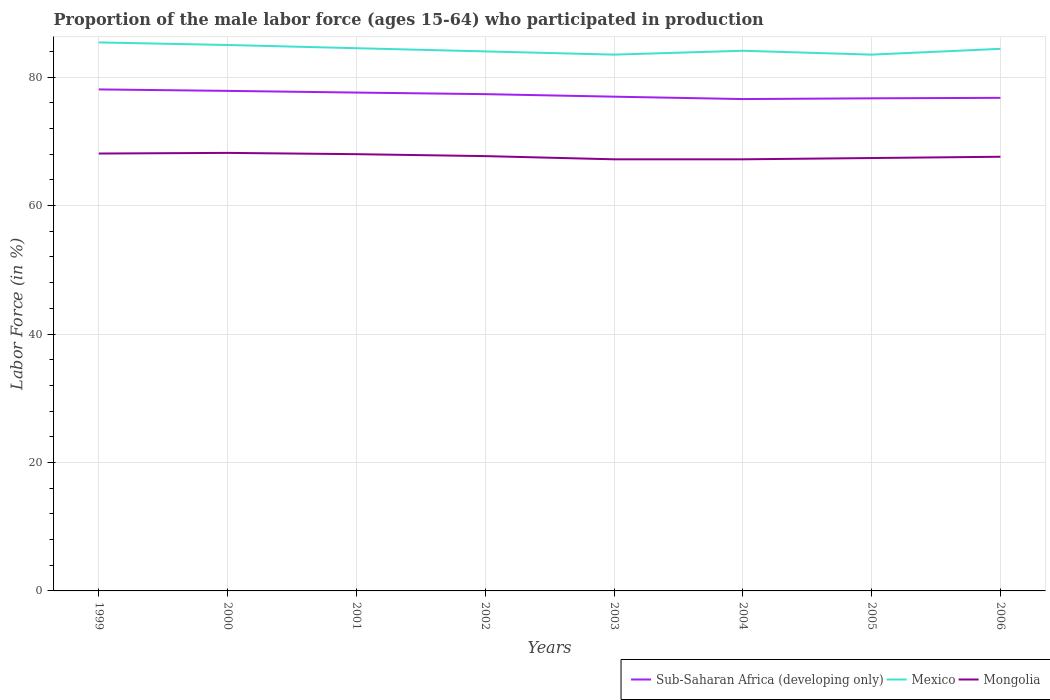Does the line corresponding to Mongolia intersect with the line corresponding to Mexico?
Your response must be concise. No. Across all years, what is the maximum proportion of the male labor force who participated in production in Sub-Saharan Africa (developing only)?
Your answer should be compact. 76.58. In which year was the proportion of the male labor force who participated in production in Mexico maximum?
Your answer should be compact. 2003. What is the total proportion of the male labor force who participated in production in Mongolia in the graph?
Your answer should be very brief. 0.5. What is the difference between the highest and the lowest proportion of the male labor force who participated in production in Mongolia?
Your answer should be very brief. 4. Are the values on the major ticks of Y-axis written in scientific E-notation?
Offer a terse response. No. Does the graph contain any zero values?
Make the answer very short. No. Where does the legend appear in the graph?
Your answer should be compact. Bottom right. How many legend labels are there?
Offer a very short reply. 3. How are the legend labels stacked?
Ensure brevity in your answer.  Horizontal. What is the title of the graph?
Offer a very short reply. Proportion of the male labor force (ages 15-64) who participated in production. What is the label or title of the Y-axis?
Provide a short and direct response. Labor Force (in %). What is the Labor Force (in %) of Sub-Saharan Africa (developing only) in 1999?
Give a very brief answer. 78.08. What is the Labor Force (in %) in Mexico in 1999?
Ensure brevity in your answer.  85.4. What is the Labor Force (in %) of Mongolia in 1999?
Your response must be concise. 68.1. What is the Labor Force (in %) of Sub-Saharan Africa (developing only) in 2000?
Your answer should be compact. 77.85. What is the Labor Force (in %) in Mongolia in 2000?
Keep it short and to the point. 68.2. What is the Labor Force (in %) in Sub-Saharan Africa (developing only) in 2001?
Give a very brief answer. 77.59. What is the Labor Force (in %) of Mexico in 2001?
Provide a short and direct response. 84.5. What is the Labor Force (in %) in Sub-Saharan Africa (developing only) in 2002?
Your answer should be compact. 77.35. What is the Labor Force (in %) of Mexico in 2002?
Offer a terse response. 84. What is the Labor Force (in %) in Mongolia in 2002?
Your answer should be very brief. 67.7. What is the Labor Force (in %) of Sub-Saharan Africa (developing only) in 2003?
Provide a succinct answer. 76.95. What is the Labor Force (in %) of Mexico in 2003?
Offer a very short reply. 83.5. What is the Labor Force (in %) of Mongolia in 2003?
Provide a short and direct response. 67.2. What is the Labor Force (in %) in Sub-Saharan Africa (developing only) in 2004?
Make the answer very short. 76.58. What is the Labor Force (in %) in Mexico in 2004?
Keep it short and to the point. 84.1. What is the Labor Force (in %) of Mongolia in 2004?
Provide a short and direct response. 67.2. What is the Labor Force (in %) of Sub-Saharan Africa (developing only) in 2005?
Your response must be concise. 76.7. What is the Labor Force (in %) of Mexico in 2005?
Your response must be concise. 83.5. What is the Labor Force (in %) of Mongolia in 2005?
Give a very brief answer. 67.4. What is the Labor Force (in %) in Sub-Saharan Africa (developing only) in 2006?
Make the answer very short. 76.77. What is the Labor Force (in %) of Mexico in 2006?
Offer a very short reply. 84.4. What is the Labor Force (in %) of Mongolia in 2006?
Ensure brevity in your answer.  67.6. Across all years, what is the maximum Labor Force (in %) of Sub-Saharan Africa (developing only)?
Ensure brevity in your answer.  78.08. Across all years, what is the maximum Labor Force (in %) of Mexico?
Offer a very short reply. 85.4. Across all years, what is the maximum Labor Force (in %) of Mongolia?
Provide a short and direct response. 68.2. Across all years, what is the minimum Labor Force (in %) in Sub-Saharan Africa (developing only)?
Make the answer very short. 76.58. Across all years, what is the minimum Labor Force (in %) in Mexico?
Provide a succinct answer. 83.5. Across all years, what is the minimum Labor Force (in %) in Mongolia?
Ensure brevity in your answer.  67.2. What is the total Labor Force (in %) of Sub-Saharan Africa (developing only) in the graph?
Give a very brief answer. 617.88. What is the total Labor Force (in %) in Mexico in the graph?
Your answer should be compact. 674.4. What is the total Labor Force (in %) of Mongolia in the graph?
Your response must be concise. 541.4. What is the difference between the Labor Force (in %) of Sub-Saharan Africa (developing only) in 1999 and that in 2000?
Your answer should be compact. 0.23. What is the difference between the Labor Force (in %) in Mongolia in 1999 and that in 2000?
Offer a very short reply. -0.1. What is the difference between the Labor Force (in %) in Sub-Saharan Africa (developing only) in 1999 and that in 2001?
Your answer should be very brief. 0.49. What is the difference between the Labor Force (in %) of Mexico in 1999 and that in 2001?
Make the answer very short. 0.9. What is the difference between the Labor Force (in %) in Sub-Saharan Africa (developing only) in 1999 and that in 2002?
Your response must be concise. 0.73. What is the difference between the Labor Force (in %) of Mongolia in 1999 and that in 2002?
Give a very brief answer. 0.4. What is the difference between the Labor Force (in %) of Sub-Saharan Africa (developing only) in 1999 and that in 2003?
Give a very brief answer. 1.13. What is the difference between the Labor Force (in %) in Sub-Saharan Africa (developing only) in 1999 and that in 2004?
Provide a short and direct response. 1.5. What is the difference between the Labor Force (in %) of Mongolia in 1999 and that in 2004?
Offer a terse response. 0.9. What is the difference between the Labor Force (in %) of Sub-Saharan Africa (developing only) in 1999 and that in 2005?
Give a very brief answer. 1.38. What is the difference between the Labor Force (in %) in Mexico in 1999 and that in 2005?
Ensure brevity in your answer.  1.9. What is the difference between the Labor Force (in %) of Sub-Saharan Africa (developing only) in 1999 and that in 2006?
Make the answer very short. 1.31. What is the difference between the Labor Force (in %) of Mexico in 1999 and that in 2006?
Your answer should be very brief. 1. What is the difference between the Labor Force (in %) of Mongolia in 1999 and that in 2006?
Provide a succinct answer. 0.5. What is the difference between the Labor Force (in %) of Sub-Saharan Africa (developing only) in 2000 and that in 2001?
Provide a short and direct response. 0.26. What is the difference between the Labor Force (in %) of Mongolia in 2000 and that in 2001?
Give a very brief answer. 0.2. What is the difference between the Labor Force (in %) in Sub-Saharan Africa (developing only) in 2000 and that in 2002?
Provide a succinct answer. 0.51. What is the difference between the Labor Force (in %) of Mexico in 2000 and that in 2002?
Keep it short and to the point. 1. What is the difference between the Labor Force (in %) of Mongolia in 2000 and that in 2002?
Your answer should be compact. 0.5. What is the difference between the Labor Force (in %) in Sub-Saharan Africa (developing only) in 2000 and that in 2003?
Offer a very short reply. 0.9. What is the difference between the Labor Force (in %) in Mexico in 2000 and that in 2003?
Provide a short and direct response. 1.5. What is the difference between the Labor Force (in %) in Mongolia in 2000 and that in 2003?
Keep it short and to the point. 1. What is the difference between the Labor Force (in %) in Sub-Saharan Africa (developing only) in 2000 and that in 2004?
Provide a succinct answer. 1.27. What is the difference between the Labor Force (in %) of Mexico in 2000 and that in 2004?
Give a very brief answer. 0.9. What is the difference between the Labor Force (in %) of Sub-Saharan Africa (developing only) in 2000 and that in 2005?
Provide a short and direct response. 1.16. What is the difference between the Labor Force (in %) in Mexico in 2000 and that in 2005?
Provide a short and direct response. 1.5. What is the difference between the Labor Force (in %) in Mongolia in 2000 and that in 2005?
Offer a terse response. 0.8. What is the difference between the Labor Force (in %) in Sub-Saharan Africa (developing only) in 2000 and that in 2006?
Ensure brevity in your answer.  1.09. What is the difference between the Labor Force (in %) of Mexico in 2000 and that in 2006?
Provide a short and direct response. 0.6. What is the difference between the Labor Force (in %) of Mongolia in 2000 and that in 2006?
Provide a short and direct response. 0.6. What is the difference between the Labor Force (in %) of Sub-Saharan Africa (developing only) in 2001 and that in 2002?
Ensure brevity in your answer.  0.24. What is the difference between the Labor Force (in %) in Sub-Saharan Africa (developing only) in 2001 and that in 2003?
Your answer should be compact. 0.64. What is the difference between the Labor Force (in %) of Mexico in 2001 and that in 2003?
Offer a very short reply. 1. What is the difference between the Labor Force (in %) in Sub-Saharan Africa (developing only) in 2001 and that in 2004?
Keep it short and to the point. 1.01. What is the difference between the Labor Force (in %) of Mexico in 2001 and that in 2004?
Your response must be concise. 0.4. What is the difference between the Labor Force (in %) of Mongolia in 2001 and that in 2004?
Give a very brief answer. 0.8. What is the difference between the Labor Force (in %) in Sub-Saharan Africa (developing only) in 2001 and that in 2005?
Provide a short and direct response. 0.9. What is the difference between the Labor Force (in %) of Sub-Saharan Africa (developing only) in 2001 and that in 2006?
Give a very brief answer. 0.82. What is the difference between the Labor Force (in %) in Mongolia in 2001 and that in 2006?
Provide a short and direct response. 0.4. What is the difference between the Labor Force (in %) in Sub-Saharan Africa (developing only) in 2002 and that in 2003?
Your response must be concise. 0.4. What is the difference between the Labor Force (in %) of Mexico in 2002 and that in 2003?
Give a very brief answer. 0.5. What is the difference between the Labor Force (in %) in Sub-Saharan Africa (developing only) in 2002 and that in 2004?
Your answer should be very brief. 0.77. What is the difference between the Labor Force (in %) in Mexico in 2002 and that in 2004?
Offer a terse response. -0.1. What is the difference between the Labor Force (in %) in Mongolia in 2002 and that in 2004?
Keep it short and to the point. 0.5. What is the difference between the Labor Force (in %) of Sub-Saharan Africa (developing only) in 2002 and that in 2005?
Give a very brief answer. 0.65. What is the difference between the Labor Force (in %) in Sub-Saharan Africa (developing only) in 2002 and that in 2006?
Your response must be concise. 0.58. What is the difference between the Labor Force (in %) of Mexico in 2002 and that in 2006?
Make the answer very short. -0.4. What is the difference between the Labor Force (in %) of Sub-Saharan Africa (developing only) in 2003 and that in 2004?
Your answer should be very brief. 0.37. What is the difference between the Labor Force (in %) in Mexico in 2003 and that in 2004?
Offer a very short reply. -0.6. What is the difference between the Labor Force (in %) in Sub-Saharan Africa (developing only) in 2003 and that in 2005?
Offer a terse response. 0.26. What is the difference between the Labor Force (in %) of Mexico in 2003 and that in 2005?
Ensure brevity in your answer.  0. What is the difference between the Labor Force (in %) of Sub-Saharan Africa (developing only) in 2003 and that in 2006?
Your answer should be compact. 0.18. What is the difference between the Labor Force (in %) in Mexico in 2003 and that in 2006?
Your response must be concise. -0.9. What is the difference between the Labor Force (in %) in Mongolia in 2003 and that in 2006?
Keep it short and to the point. -0.4. What is the difference between the Labor Force (in %) in Sub-Saharan Africa (developing only) in 2004 and that in 2005?
Offer a very short reply. -0.12. What is the difference between the Labor Force (in %) of Mexico in 2004 and that in 2005?
Keep it short and to the point. 0.6. What is the difference between the Labor Force (in %) in Sub-Saharan Africa (developing only) in 2004 and that in 2006?
Ensure brevity in your answer.  -0.19. What is the difference between the Labor Force (in %) of Mexico in 2004 and that in 2006?
Your answer should be compact. -0.3. What is the difference between the Labor Force (in %) of Sub-Saharan Africa (developing only) in 2005 and that in 2006?
Your response must be concise. -0.07. What is the difference between the Labor Force (in %) of Mexico in 2005 and that in 2006?
Offer a terse response. -0.9. What is the difference between the Labor Force (in %) of Mongolia in 2005 and that in 2006?
Offer a terse response. -0.2. What is the difference between the Labor Force (in %) in Sub-Saharan Africa (developing only) in 1999 and the Labor Force (in %) in Mexico in 2000?
Provide a succinct answer. -6.92. What is the difference between the Labor Force (in %) in Sub-Saharan Africa (developing only) in 1999 and the Labor Force (in %) in Mongolia in 2000?
Your answer should be compact. 9.88. What is the difference between the Labor Force (in %) in Sub-Saharan Africa (developing only) in 1999 and the Labor Force (in %) in Mexico in 2001?
Make the answer very short. -6.42. What is the difference between the Labor Force (in %) of Sub-Saharan Africa (developing only) in 1999 and the Labor Force (in %) of Mongolia in 2001?
Provide a short and direct response. 10.08. What is the difference between the Labor Force (in %) in Mexico in 1999 and the Labor Force (in %) in Mongolia in 2001?
Ensure brevity in your answer.  17.4. What is the difference between the Labor Force (in %) of Sub-Saharan Africa (developing only) in 1999 and the Labor Force (in %) of Mexico in 2002?
Your answer should be very brief. -5.92. What is the difference between the Labor Force (in %) in Sub-Saharan Africa (developing only) in 1999 and the Labor Force (in %) in Mongolia in 2002?
Your answer should be compact. 10.38. What is the difference between the Labor Force (in %) in Mexico in 1999 and the Labor Force (in %) in Mongolia in 2002?
Give a very brief answer. 17.7. What is the difference between the Labor Force (in %) of Sub-Saharan Africa (developing only) in 1999 and the Labor Force (in %) of Mexico in 2003?
Ensure brevity in your answer.  -5.42. What is the difference between the Labor Force (in %) in Sub-Saharan Africa (developing only) in 1999 and the Labor Force (in %) in Mongolia in 2003?
Offer a terse response. 10.88. What is the difference between the Labor Force (in %) in Sub-Saharan Africa (developing only) in 1999 and the Labor Force (in %) in Mexico in 2004?
Provide a succinct answer. -6.02. What is the difference between the Labor Force (in %) in Sub-Saharan Africa (developing only) in 1999 and the Labor Force (in %) in Mongolia in 2004?
Give a very brief answer. 10.88. What is the difference between the Labor Force (in %) of Sub-Saharan Africa (developing only) in 1999 and the Labor Force (in %) of Mexico in 2005?
Your answer should be compact. -5.42. What is the difference between the Labor Force (in %) in Sub-Saharan Africa (developing only) in 1999 and the Labor Force (in %) in Mongolia in 2005?
Your response must be concise. 10.68. What is the difference between the Labor Force (in %) of Mexico in 1999 and the Labor Force (in %) of Mongolia in 2005?
Your response must be concise. 18. What is the difference between the Labor Force (in %) in Sub-Saharan Africa (developing only) in 1999 and the Labor Force (in %) in Mexico in 2006?
Provide a succinct answer. -6.32. What is the difference between the Labor Force (in %) of Sub-Saharan Africa (developing only) in 1999 and the Labor Force (in %) of Mongolia in 2006?
Offer a very short reply. 10.48. What is the difference between the Labor Force (in %) of Mexico in 1999 and the Labor Force (in %) of Mongolia in 2006?
Keep it short and to the point. 17.8. What is the difference between the Labor Force (in %) of Sub-Saharan Africa (developing only) in 2000 and the Labor Force (in %) of Mexico in 2001?
Offer a very short reply. -6.65. What is the difference between the Labor Force (in %) in Sub-Saharan Africa (developing only) in 2000 and the Labor Force (in %) in Mongolia in 2001?
Your answer should be very brief. 9.85. What is the difference between the Labor Force (in %) of Sub-Saharan Africa (developing only) in 2000 and the Labor Force (in %) of Mexico in 2002?
Give a very brief answer. -6.15. What is the difference between the Labor Force (in %) in Sub-Saharan Africa (developing only) in 2000 and the Labor Force (in %) in Mongolia in 2002?
Make the answer very short. 10.15. What is the difference between the Labor Force (in %) of Sub-Saharan Africa (developing only) in 2000 and the Labor Force (in %) of Mexico in 2003?
Give a very brief answer. -5.65. What is the difference between the Labor Force (in %) of Sub-Saharan Africa (developing only) in 2000 and the Labor Force (in %) of Mongolia in 2003?
Provide a short and direct response. 10.65. What is the difference between the Labor Force (in %) of Mexico in 2000 and the Labor Force (in %) of Mongolia in 2003?
Your answer should be very brief. 17.8. What is the difference between the Labor Force (in %) of Sub-Saharan Africa (developing only) in 2000 and the Labor Force (in %) of Mexico in 2004?
Keep it short and to the point. -6.25. What is the difference between the Labor Force (in %) in Sub-Saharan Africa (developing only) in 2000 and the Labor Force (in %) in Mongolia in 2004?
Give a very brief answer. 10.65. What is the difference between the Labor Force (in %) of Mexico in 2000 and the Labor Force (in %) of Mongolia in 2004?
Give a very brief answer. 17.8. What is the difference between the Labor Force (in %) of Sub-Saharan Africa (developing only) in 2000 and the Labor Force (in %) of Mexico in 2005?
Ensure brevity in your answer.  -5.65. What is the difference between the Labor Force (in %) in Sub-Saharan Africa (developing only) in 2000 and the Labor Force (in %) in Mongolia in 2005?
Offer a very short reply. 10.45. What is the difference between the Labor Force (in %) of Mexico in 2000 and the Labor Force (in %) of Mongolia in 2005?
Provide a succinct answer. 17.6. What is the difference between the Labor Force (in %) in Sub-Saharan Africa (developing only) in 2000 and the Labor Force (in %) in Mexico in 2006?
Offer a very short reply. -6.55. What is the difference between the Labor Force (in %) in Sub-Saharan Africa (developing only) in 2000 and the Labor Force (in %) in Mongolia in 2006?
Keep it short and to the point. 10.25. What is the difference between the Labor Force (in %) in Mexico in 2000 and the Labor Force (in %) in Mongolia in 2006?
Make the answer very short. 17.4. What is the difference between the Labor Force (in %) in Sub-Saharan Africa (developing only) in 2001 and the Labor Force (in %) in Mexico in 2002?
Keep it short and to the point. -6.41. What is the difference between the Labor Force (in %) in Sub-Saharan Africa (developing only) in 2001 and the Labor Force (in %) in Mongolia in 2002?
Give a very brief answer. 9.89. What is the difference between the Labor Force (in %) in Mexico in 2001 and the Labor Force (in %) in Mongolia in 2002?
Offer a very short reply. 16.8. What is the difference between the Labor Force (in %) in Sub-Saharan Africa (developing only) in 2001 and the Labor Force (in %) in Mexico in 2003?
Your answer should be compact. -5.91. What is the difference between the Labor Force (in %) of Sub-Saharan Africa (developing only) in 2001 and the Labor Force (in %) of Mongolia in 2003?
Your answer should be compact. 10.39. What is the difference between the Labor Force (in %) in Sub-Saharan Africa (developing only) in 2001 and the Labor Force (in %) in Mexico in 2004?
Make the answer very short. -6.51. What is the difference between the Labor Force (in %) in Sub-Saharan Africa (developing only) in 2001 and the Labor Force (in %) in Mongolia in 2004?
Your answer should be compact. 10.39. What is the difference between the Labor Force (in %) of Mexico in 2001 and the Labor Force (in %) of Mongolia in 2004?
Provide a short and direct response. 17.3. What is the difference between the Labor Force (in %) in Sub-Saharan Africa (developing only) in 2001 and the Labor Force (in %) in Mexico in 2005?
Your answer should be compact. -5.91. What is the difference between the Labor Force (in %) of Sub-Saharan Africa (developing only) in 2001 and the Labor Force (in %) of Mongolia in 2005?
Your answer should be very brief. 10.19. What is the difference between the Labor Force (in %) of Mexico in 2001 and the Labor Force (in %) of Mongolia in 2005?
Offer a very short reply. 17.1. What is the difference between the Labor Force (in %) of Sub-Saharan Africa (developing only) in 2001 and the Labor Force (in %) of Mexico in 2006?
Your answer should be compact. -6.81. What is the difference between the Labor Force (in %) in Sub-Saharan Africa (developing only) in 2001 and the Labor Force (in %) in Mongolia in 2006?
Provide a short and direct response. 9.99. What is the difference between the Labor Force (in %) in Sub-Saharan Africa (developing only) in 2002 and the Labor Force (in %) in Mexico in 2003?
Keep it short and to the point. -6.15. What is the difference between the Labor Force (in %) of Sub-Saharan Africa (developing only) in 2002 and the Labor Force (in %) of Mongolia in 2003?
Offer a very short reply. 10.15. What is the difference between the Labor Force (in %) in Sub-Saharan Africa (developing only) in 2002 and the Labor Force (in %) in Mexico in 2004?
Keep it short and to the point. -6.75. What is the difference between the Labor Force (in %) of Sub-Saharan Africa (developing only) in 2002 and the Labor Force (in %) of Mongolia in 2004?
Offer a very short reply. 10.15. What is the difference between the Labor Force (in %) of Mexico in 2002 and the Labor Force (in %) of Mongolia in 2004?
Your response must be concise. 16.8. What is the difference between the Labor Force (in %) in Sub-Saharan Africa (developing only) in 2002 and the Labor Force (in %) in Mexico in 2005?
Provide a short and direct response. -6.15. What is the difference between the Labor Force (in %) of Sub-Saharan Africa (developing only) in 2002 and the Labor Force (in %) of Mongolia in 2005?
Your answer should be very brief. 9.95. What is the difference between the Labor Force (in %) in Sub-Saharan Africa (developing only) in 2002 and the Labor Force (in %) in Mexico in 2006?
Ensure brevity in your answer.  -7.05. What is the difference between the Labor Force (in %) in Sub-Saharan Africa (developing only) in 2002 and the Labor Force (in %) in Mongolia in 2006?
Your answer should be compact. 9.75. What is the difference between the Labor Force (in %) in Mexico in 2002 and the Labor Force (in %) in Mongolia in 2006?
Provide a succinct answer. 16.4. What is the difference between the Labor Force (in %) of Sub-Saharan Africa (developing only) in 2003 and the Labor Force (in %) of Mexico in 2004?
Provide a short and direct response. -7.15. What is the difference between the Labor Force (in %) of Sub-Saharan Africa (developing only) in 2003 and the Labor Force (in %) of Mongolia in 2004?
Your response must be concise. 9.75. What is the difference between the Labor Force (in %) of Mexico in 2003 and the Labor Force (in %) of Mongolia in 2004?
Your answer should be compact. 16.3. What is the difference between the Labor Force (in %) in Sub-Saharan Africa (developing only) in 2003 and the Labor Force (in %) in Mexico in 2005?
Provide a succinct answer. -6.55. What is the difference between the Labor Force (in %) of Sub-Saharan Africa (developing only) in 2003 and the Labor Force (in %) of Mongolia in 2005?
Your answer should be very brief. 9.55. What is the difference between the Labor Force (in %) in Mexico in 2003 and the Labor Force (in %) in Mongolia in 2005?
Provide a short and direct response. 16.1. What is the difference between the Labor Force (in %) of Sub-Saharan Africa (developing only) in 2003 and the Labor Force (in %) of Mexico in 2006?
Offer a terse response. -7.45. What is the difference between the Labor Force (in %) in Sub-Saharan Africa (developing only) in 2003 and the Labor Force (in %) in Mongolia in 2006?
Your response must be concise. 9.35. What is the difference between the Labor Force (in %) in Sub-Saharan Africa (developing only) in 2004 and the Labor Force (in %) in Mexico in 2005?
Your answer should be very brief. -6.92. What is the difference between the Labor Force (in %) of Sub-Saharan Africa (developing only) in 2004 and the Labor Force (in %) of Mongolia in 2005?
Your response must be concise. 9.18. What is the difference between the Labor Force (in %) in Mexico in 2004 and the Labor Force (in %) in Mongolia in 2005?
Your answer should be very brief. 16.7. What is the difference between the Labor Force (in %) in Sub-Saharan Africa (developing only) in 2004 and the Labor Force (in %) in Mexico in 2006?
Your response must be concise. -7.82. What is the difference between the Labor Force (in %) of Sub-Saharan Africa (developing only) in 2004 and the Labor Force (in %) of Mongolia in 2006?
Keep it short and to the point. 8.98. What is the difference between the Labor Force (in %) of Mexico in 2004 and the Labor Force (in %) of Mongolia in 2006?
Your response must be concise. 16.5. What is the difference between the Labor Force (in %) in Sub-Saharan Africa (developing only) in 2005 and the Labor Force (in %) in Mexico in 2006?
Your response must be concise. -7.7. What is the difference between the Labor Force (in %) of Sub-Saharan Africa (developing only) in 2005 and the Labor Force (in %) of Mongolia in 2006?
Offer a very short reply. 9.1. What is the average Labor Force (in %) in Sub-Saharan Africa (developing only) per year?
Offer a very short reply. 77.23. What is the average Labor Force (in %) in Mexico per year?
Offer a terse response. 84.3. What is the average Labor Force (in %) of Mongolia per year?
Offer a terse response. 67.67. In the year 1999, what is the difference between the Labor Force (in %) in Sub-Saharan Africa (developing only) and Labor Force (in %) in Mexico?
Offer a terse response. -7.32. In the year 1999, what is the difference between the Labor Force (in %) in Sub-Saharan Africa (developing only) and Labor Force (in %) in Mongolia?
Provide a short and direct response. 9.98. In the year 1999, what is the difference between the Labor Force (in %) of Mexico and Labor Force (in %) of Mongolia?
Your answer should be very brief. 17.3. In the year 2000, what is the difference between the Labor Force (in %) of Sub-Saharan Africa (developing only) and Labor Force (in %) of Mexico?
Make the answer very short. -7.15. In the year 2000, what is the difference between the Labor Force (in %) of Sub-Saharan Africa (developing only) and Labor Force (in %) of Mongolia?
Offer a terse response. 9.65. In the year 2001, what is the difference between the Labor Force (in %) of Sub-Saharan Africa (developing only) and Labor Force (in %) of Mexico?
Give a very brief answer. -6.91. In the year 2001, what is the difference between the Labor Force (in %) in Sub-Saharan Africa (developing only) and Labor Force (in %) in Mongolia?
Make the answer very short. 9.59. In the year 2002, what is the difference between the Labor Force (in %) of Sub-Saharan Africa (developing only) and Labor Force (in %) of Mexico?
Offer a terse response. -6.65. In the year 2002, what is the difference between the Labor Force (in %) in Sub-Saharan Africa (developing only) and Labor Force (in %) in Mongolia?
Make the answer very short. 9.65. In the year 2003, what is the difference between the Labor Force (in %) of Sub-Saharan Africa (developing only) and Labor Force (in %) of Mexico?
Offer a very short reply. -6.55. In the year 2003, what is the difference between the Labor Force (in %) in Sub-Saharan Africa (developing only) and Labor Force (in %) in Mongolia?
Provide a short and direct response. 9.75. In the year 2004, what is the difference between the Labor Force (in %) in Sub-Saharan Africa (developing only) and Labor Force (in %) in Mexico?
Your response must be concise. -7.52. In the year 2004, what is the difference between the Labor Force (in %) of Sub-Saharan Africa (developing only) and Labor Force (in %) of Mongolia?
Make the answer very short. 9.38. In the year 2005, what is the difference between the Labor Force (in %) of Sub-Saharan Africa (developing only) and Labor Force (in %) of Mexico?
Your answer should be compact. -6.8. In the year 2005, what is the difference between the Labor Force (in %) of Sub-Saharan Africa (developing only) and Labor Force (in %) of Mongolia?
Your answer should be compact. 9.3. In the year 2006, what is the difference between the Labor Force (in %) of Sub-Saharan Africa (developing only) and Labor Force (in %) of Mexico?
Provide a succinct answer. -7.63. In the year 2006, what is the difference between the Labor Force (in %) of Sub-Saharan Africa (developing only) and Labor Force (in %) of Mongolia?
Make the answer very short. 9.17. In the year 2006, what is the difference between the Labor Force (in %) in Mexico and Labor Force (in %) in Mongolia?
Your response must be concise. 16.8. What is the ratio of the Labor Force (in %) in Mongolia in 1999 to that in 2000?
Give a very brief answer. 1. What is the ratio of the Labor Force (in %) in Mexico in 1999 to that in 2001?
Ensure brevity in your answer.  1.01. What is the ratio of the Labor Force (in %) of Sub-Saharan Africa (developing only) in 1999 to that in 2002?
Give a very brief answer. 1.01. What is the ratio of the Labor Force (in %) of Mexico in 1999 to that in 2002?
Ensure brevity in your answer.  1.02. What is the ratio of the Labor Force (in %) in Mongolia in 1999 to that in 2002?
Give a very brief answer. 1.01. What is the ratio of the Labor Force (in %) of Sub-Saharan Africa (developing only) in 1999 to that in 2003?
Your answer should be compact. 1.01. What is the ratio of the Labor Force (in %) of Mexico in 1999 to that in 2003?
Your answer should be very brief. 1.02. What is the ratio of the Labor Force (in %) in Mongolia in 1999 to that in 2003?
Your answer should be very brief. 1.01. What is the ratio of the Labor Force (in %) in Sub-Saharan Africa (developing only) in 1999 to that in 2004?
Give a very brief answer. 1.02. What is the ratio of the Labor Force (in %) in Mexico in 1999 to that in 2004?
Your response must be concise. 1.02. What is the ratio of the Labor Force (in %) of Mongolia in 1999 to that in 2004?
Your response must be concise. 1.01. What is the ratio of the Labor Force (in %) of Mexico in 1999 to that in 2005?
Make the answer very short. 1.02. What is the ratio of the Labor Force (in %) in Mongolia in 1999 to that in 2005?
Make the answer very short. 1.01. What is the ratio of the Labor Force (in %) in Sub-Saharan Africa (developing only) in 1999 to that in 2006?
Your response must be concise. 1.02. What is the ratio of the Labor Force (in %) in Mexico in 1999 to that in 2006?
Provide a short and direct response. 1.01. What is the ratio of the Labor Force (in %) in Mongolia in 1999 to that in 2006?
Offer a terse response. 1.01. What is the ratio of the Labor Force (in %) of Sub-Saharan Africa (developing only) in 2000 to that in 2001?
Keep it short and to the point. 1. What is the ratio of the Labor Force (in %) in Mexico in 2000 to that in 2001?
Your response must be concise. 1.01. What is the ratio of the Labor Force (in %) of Mongolia in 2000 to that in 2001?
Provide a short and direct response. 1. What is the ratio of the Labor Force (in %) in Sub-Saharan Africa (developing only) in 2000 to that in 2002?
Provide a short and direct response. 1.01. What is the ratio of the Labor Force (in %) of Mexico in 2000 to that in 2002?
Your answer should be very brief. 1.01. What is the ratio of the Labor Force (in %) of Mongolia in 2000 to that in 2002?
Make the answer very short. 1.01. What is the ratio of the Labor Force (in %) in Sub-Saharan Africa (developing only) in 2000 to that in 2003?
Your answer should be compact. 1.01. What is the ratio of the Labor Force (in %) in Mongolia in 2000 to that in 2003?
Provide a succinct answer. 1.01. What is the ratio of the Labor Force (in %) of Sub-Saharan Africa (developing only) in 2000 to that in 2004?
Ensure brevity in your answer.  1.02. What is the ratio of the Labor Force (in %) in Mexico in 2000 to that in 2004?
Keep it short and to the point. 1.01. What is the ratio of the Labor Force (in %) of Mongolia in 2000 to that in 2004?
Provide a short and direct response. 1.01. What is the ratio of the Labor Force (in %) in Sub-Saharan Africa (developing only) in 2000 to that in 2005?
Offer a very short reply. 1.02. What is the ratio of the Labor Force (in %) in Mexico in 2000 to that in 2005?
Keep it short and to the point. 1.02. What is the ratio of the Labor Force (in %) of Mongolia in 2000 to that in 2005?
Your response must be concise. 1.01. What is the ratio of the Labor Force (in %) in Sub-Saharan Africa (developing only) in 2000 to that in 2006?
Provide a short and direct response. 1.01. What is the ratio of the Labor Force (in %) in Mexico in 2000 to that in 2006?
Provide a short and direct response. 1.01. What is the ratio of the Labor Force (in %) in Mongolia in 2000 to that in 2006?
Your answer should be compact. 1.01. What is the ratio of the Labor Force (in %) in Mexico in 2001 to that in 2002?
Provide a short and direct response. 1.01. What is the ratio of the Labor Force (in %) of Sub-Saharan Africa (developing only) in 2001 to that in 2003?
Provide a short and direct response. 1.01. What is the ratio of the Labor Force (in %) in Mexico in 2001 to that in 2003?
Provide a succinct answer. 1.01. What is the ratio of the Labor Force (in %) in Mongolia in 2001 to that in 2003?
Provide a succinct answer. 1.01. What is the ratio of the Labor Force (in %) in Sub-Saharan Africa (developing only) in 2001 to that in 2004?
Offer a terse response. 1.01. What is the ratio of the Labor Force (in %) of Mongolia in 2001 to that in 2004?
Provide a short and direct response. 1.01. What is the ratio of the Labor Force (in %) in Sub-Saharan Africa (developing only) in 2001 to that in 2005?
Keep it short and to the point. 1.01. What is the ratio of the Labor Force (in %) of Mexico in 2001 to that in 2005?
Provide a succinct answer. 1.01. What is the ratio of the Labor Force (in %) in Mongolia in 2001 to that in 2005?
Offer a very short reply. 1.01. What is the ratio of the Labor Force (in %) of Sub-Saharan Africa (developing only) in 2001 to that in 2006?
Keep it short and to the point. 1.01. What is the ratio of the Labor Force (in %) of Mongolia in 2001 to that in 2006?
Ensure brevity in your answer.  1.01. What is the ratio of the Labor Force (in %) in Mexico in 2002 to that in 2003?
Your response must be concise. 1.01. What is the ratio of the Labor Force (in %) of Mongolia in 2002 to that in 2003?
Provide a short and direct response. 1.01. What is the ratio of the Labor Force (in %) of Sub-Saharan Africa (developing only) in 2002 to that in 2004?
Provide a succinct answer. 1.01. What is the ratio of the Labor Force (in %) of Mongolia in 2002 to that in 2004?
Provide a short and direct response. 1.01. What is the ratio of the Labor Force (in %) in Sub-Saharan Africa (developing only) in 2002 to that in 2005?
Your answer should be very brief. 1.01. What is the ratio of the Labor Force (in %) of Mongolia in 2002 to that in 2005?
Give a very brief answer. 1. What is the ratio of the Labor Force (in %) of Sub-Saharan Africa (developing only) in 2002 to that in 2006?
Provide a short and direct response. 1.01. What is the ratio of the Labor Force (in %) of Mexico in 2002 to that in 2006?
Provide a succinct answer. 1. What is the ratio of the Labor Force (in %) of Sub-Saharan Africa (developing only) in 2003 to that in 2004?
Provide a succinct answer. 1. What is the ratio of the Labor Force (in %) of Mexico in 2003 to that in 2004?
Offer a terse response. 0.99. What is the ratio of the Labor Force (in %) in Mexico in 2003 to that in 2005?
Your answer should be compact. 1. What is the ratio of the Labor Force (in %) of Mongolia in 2003 to that in 2005?
Your answer should be very brief. 1. What is the ratio of the Labor Force (in %) in Sub-Saharan Africa (developing only) in 2003 to that in 2006?
Your answer should be compact. 1. What is the ratio of the Labor Force (in %) of Mexico in 2003 to that in 2006?
Offer a terse response. 0.99. What is the ratio of the Labor Force (in %) in Mongolia in 2003 to that in 2006?
Your response must be concise. 0.99. What is the ratio of the Labor Force (in %) in Mexico in 2004 to that in 2006?
Provide a succinct answer. 1. What is the ratio of the Labor Force (in %) of Mexico in 2005 to that in 2006?
Offer a very short reply. 0.99. What is the ratio of the Labor Force (in %) in Mongolia in 2005 to that in 2006?
Keep it short and to the point. 1. What is the difference between the highest and the second highest Labor Force (in %) of Sub-Saharan Africa (developing only)?
Give a very brief answer. 0.23. What is the difference between the highest and the second highest Labor Force (in %) in Mexico?
Give a very brief answer. 0.4. What is the difference between the highest and the lowest Labor Force (in %) of Sub-Saharan Africa (developing only)?
Keep it short and to the point. 1.5. What is the difference between the highest and the lowest Labor Force (in %) in Mexico?
Provide a succinct answer. 1.9. What is the difference between the highest and the lowest Labor Force (in %) of Mongolia?
Offer a very short reply. 1. 